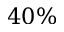<formula> <loc_0><loc_0><loc_500><loc_500>4 0 \%</formula> 